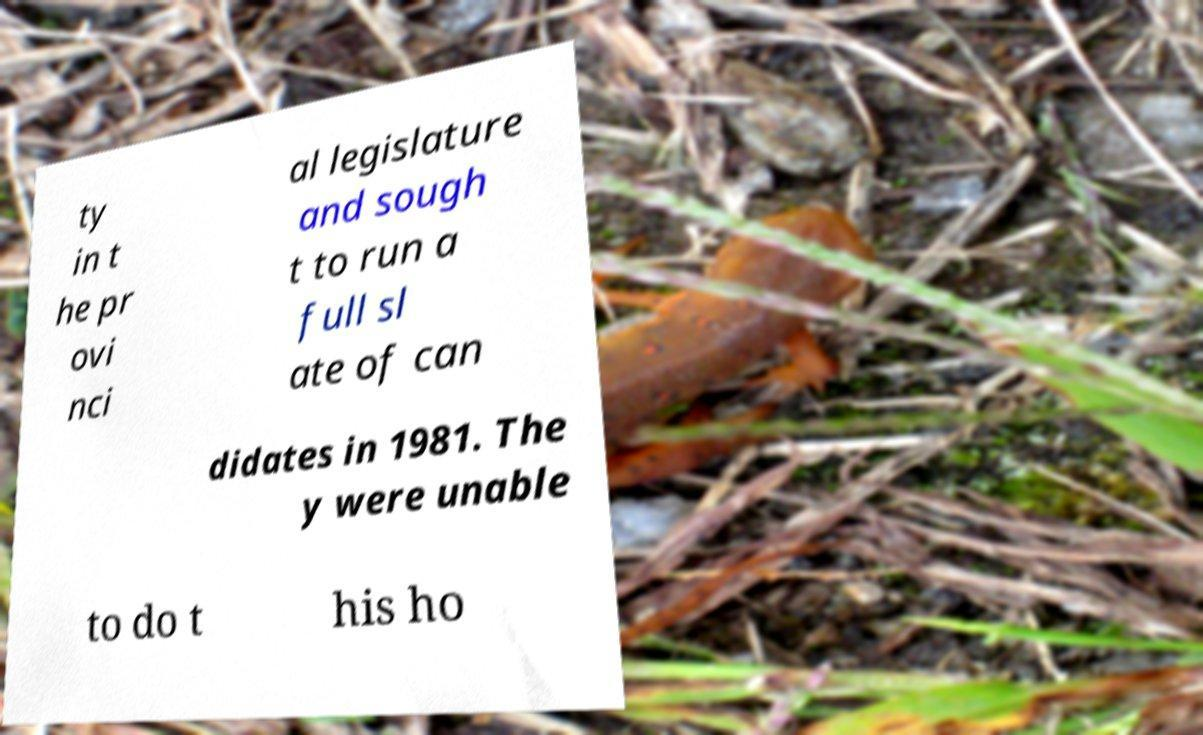Please read and relay the text visible in this image. What does it say? ty in t he pr ovi nci al legislature and sough t to run a full sl ate of can didates in 1981. The y were unable to do t his ho 